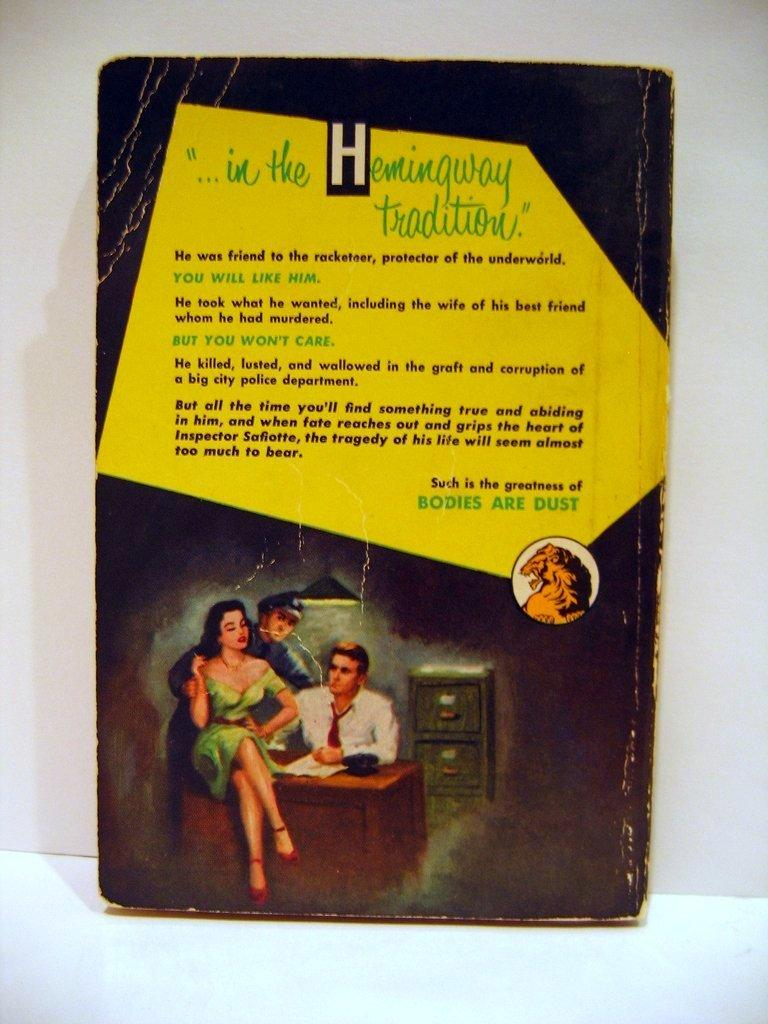Provide a one-sentence caption for the provided image. The back of a book talks about the book, stating that Bodies are Dust. 